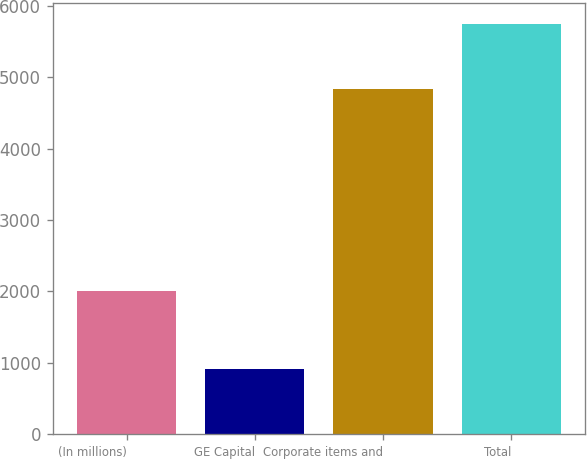Convert chart to OTSL. <chart><loc_0><loc_0><loc_500><loc_500><bar_chart><fcel>(In millions)<fcel>GE Capital<fcel>Corporate items and<fcel>Total<nl><fcel>2011<fcel>906<fcel>4839<fcel>5745<nl></chart> 